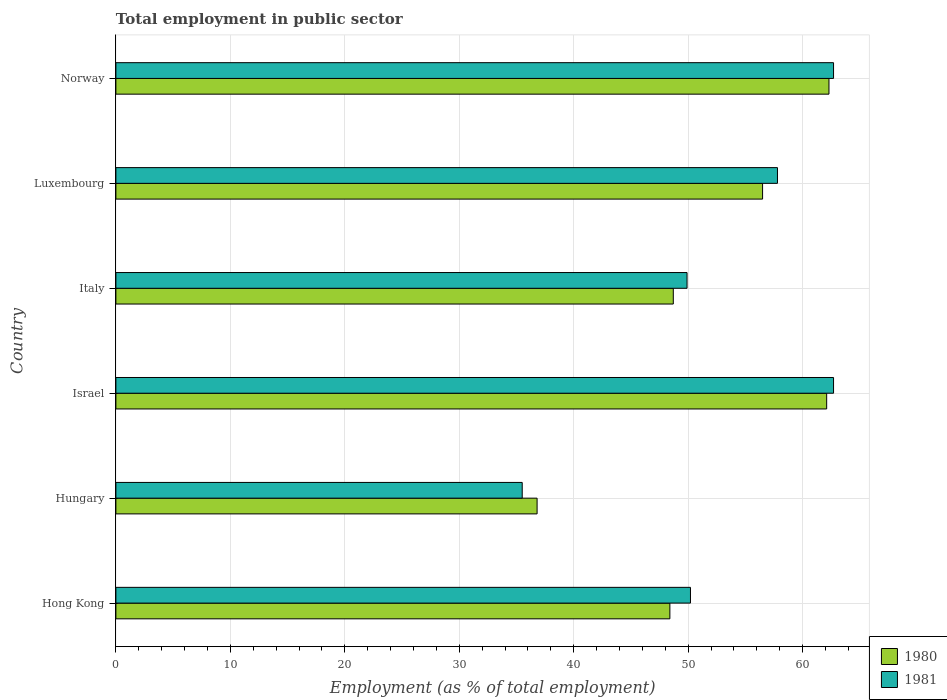How many groups of bars are there?
Keep it short and to the point. 6. How many bars are there on the 2nd tick from the top?
Offer a terse response. 2. What is the label of the 6th group of bars from the top?
Ensure brevity in your answer.  Hong Kong. What is the employment in public sector in 1980 in Luxembourg?
Keep it short and to the point. 56.5. Across all countries, what is the maximum employment in public sector in 1981?
Give a very brief answer. 62.7. Across all countries, what is the minimum employment in public sector in 1981?
Make the answer very short. 35.5. In which country was the employment in public sector in 1980 maximum?
Your response must be concise. Norway. In which country was the employment in public sector in 1980 minimum?
Your answer should be very brief. Hungary. What is the total employment in public sector in 1980 in the graph?
Make the answer very short. 314.8. What is the difference between the employment in public sector in 1981 in Hong Kong and that in Italy?
Provide a short and direct response. 0.3. What is the difference between the employment in public sector in 1981 in Luxembourg and the employment in public sector in 1980 in Italy?
Provide a short and direct response. 9.1. What is the average employment in public sector in 1981 per country?
Ensure brevity in your answer.  53.13. What is the difference between the employment in public sector in 1980 and employment in public sector in 1981 in Hungary?
Your answer should be compact. 1.3. What is the ratio of the employment in public sector in 1980 in Israel to that in Luxembourg?
Keep it short and to the point. 1.1. What is the difference between the highest and the second highest employment in public sector in 1980?
Give a very brief answer. 0.2. What is the difference between the highest and the lowest employment in public sector in 1980?
Make the answer very short. 25.5. What does the 1st bar from the top in Hungary represents?
Give a very brief answer. 1981. How many bars are there?
Provide a short and direct response. 12. Are the values on the major ticks of X-axis written in scientific E-notation?
Give a very brief answer. No. Where does the legend appear in the graph?
Offer a terse response. Bottom right. How many legend labels are there?
Provide a succinct answer. 2. What is the title of the graph?
Your answer should be compact. Total employment in public sector. What is the label or title of the X-axis?
Your response must be concise. Employment (as % of total employment). What is the Employment (as % of total employment) of 1980 in Hong Kong?
Your answer should be compact. 48.4. What is the Employment (as % of total employment) of 1981 in Hong Kong?
Keep it short and to the point. 50.2. What is the Employment (as % of total employment) in 1980 in Hungary?
Offer a very short reply. 36.8. What is the Employment (as % of total employment) in 1981 in Hungary?
Provide a succinct answer. 35.5. What is the Employment (as % of total employment) in 1980 in Israel?
Your answer should be compact. 62.1. What is the Employment (as % of total employment) in 1981 in Israel?
Your answer should be very brief. 62.7. What is the Employment (as % of total employment) of 1980 in Italy?
Your answer should be very brief. 48.7. What is the Employment (as % of total employment) of 1981 in Italy?
Offer a terse response. 49.9. What is the Employment (as % of total employment) of 1980 in Luxembourg?
Provide a succinct answer. 56.5. What is the Employment (as % of total employment) in 1981 in Luxembourg?
Your answer should be very brief. 57.8. What is the Employment (as % of total employment) in 1980 in Norway?
Offer a terse response. 62.3. What is the Employment (as % of total employment) of 1981 in Norway?
Make the answer very short. 62.7. Across all countries, what is the maximum Employment (as % of total employment) of 1980?
Provide a short and direct response. 62.3. Across all countries, what is the maximum Employment (as % of total employment) of 1981?
Your answer should be very brief. 62.7. Across all countries, what is the minimum Employment (as % of total employment) of 1980?
Your answer should be compact. 36.8. Across all countries, what is the minimum Employment (as % of total employment) of 1981?
Your answer should be very brief. 35.5. What is the total Employment (as % of total employment) of 1980 in the graph?
Make the answer very short. 314.8. What is the total Employment (as % of total employment) in 1981 in the graph?
Your answer should be very brief. 318.8. What is the difference between the Employment (as % of total employment) of 1980 in Hong Kong and that in Hungary?
Provide a short and direct response. 11.6. What is the difference between the Employment (as % of total employment) in 1981 in Hong Kong and that in Hungary?
Keep it short and to the point. 14.7. What is the difference between the Employment (as % of total employment) of 1980 in Hong Kong and that in Israel?
Give a very brief answer. -13.7. What is the difference between the Employment (as % of total employment) of 1981 in Hong Kong and that in Israel?
Your answer should be compact. -12.5. What is the difference between the Employment (as % of total employment) in 1981 in Hong Kong and that in Italy?
Keep it short and to the point. 0.3. What is the difference between the Employment (as % of total employment) of 1980 in Hong Kong and that in Luxembourg?
Your answer should be very brief. -8.1. What is the difference between the Employment (as % of total employment) in 1981 in Hong Kong and that in Luxembourg?
Keep it short and to the point. -7.6. What is the difference between the Employment (as % of total employment) of 1980 in Hong Kong and that in Norway?
Ensure brevity in your answer.  -13.9. What is the difference between the Employment (as % of total employment) in 1980 in Hungary and that in Israel?
Provide a short and direct response. -25.3. What is the difference between the Employment (as % of total employment) in 1981 in Hungary and that in Israel?
Offer a terse response. -27.2. What is the difference between the Employment (as % of total employment) in 1981 in Hungary and that in Italy?
Make the answer very short. -14.4. What is the difference between the Employment (as % of total employment) of 1980 in Hungary and that in Luxembourg?
Offer a terse response. -19.7. What is the difference between the Employment (as % of total employment) of 1981 in Hungary and that in Luxembourg?
Offer a terse response. -22.3. What is the difference between the Employment (as % of total employment) of 1980 in Hungary and that in Norway?
Give a very brief answer. -25.5. What is the difference between the Employment (as % of total employment) in 1981 in Hungary and that in Norway?
Offer a terse response. -27.2. What is the difference between the Employment (as % of total employment) of 1981 in Israel and that in Italy?
Offer a terse response. 12.8. What is the difference between the Employment (as % of total employment) of 1980 in Israel and that in Norway?
Keep it short and to the point. -0.2. What is the difference between the Employment (as % of total employment) of 1981 in Israel and that in Norway?
Give a very brief answer. 0. What is the difference between the Employment (as % of total employment) in 1980 in Italy and that in Luxembourg?
Make the answer very short. -7.8. What is the difference between the Employment (as % of total employment) in 1981 in Italy and that in Luxembourg?
Your response must be concise. -7.9. What is the difference between the Employment (as % of total employment) of 1981 in Italy and that in Norway?
Your answer should be compact. -12.8. What is the difference between the Employment (as % of total employment) in 1980 in Luxembourg and that in Norway?
Keep it short and to the point. -5.8. What is the difference between the Employment (as % of total employment) of 1981 in Luxembourg and that in Norway?
Your answer should be compact. -4.9. What is the difference between the Employment (as % of total employment) of 1980 in Hong Kong and the Employment (as % of total employment) of 1981 in Hungary?
Your response must be concise. 12.9. What is the difference between the Employment (as % of total employment) of 1980 in Hong Kong and the Employment (as % of total employment) of 1981 in Israel?
Ensure brevity in your answer.  -14.3. What is the difference between the Employment (as % of total employment) in 1980 in Hong Kong and the Employment (as % of total employment) in 1981 in Norway?
Provide a short and direct response. -14.3. What is the difference between the Employment (as % of total employment) of 1980 in Hungary and the Employment (as % of total employment) of 1981 in Israel?
Your answer should be very brief. -25.9. What is the difference between the Employment (as % of total employment) of 1980 in Hungary and the Employment (as % of total employment) of 1981 in Norway?
Your response must be concise. -25.9. What is the difference between the Employment (as % of total employment) in 1980 in Israel and the Employment (as % of total employment) in 1981 in Italy?
Offer a terse response. 12.2. What is the difference between the Employment (as % of total employment) of 1980 in Israel and the Employment (as % of total employment) of 1981 in Norway?
Offer a terse response. -0.6. What is the difference between the Employment (as % of total employment) in 1980 in Italy and the Employment (as % of total employment) in 1981 in Norway?
Offer a terse response. -14. What is the average Employment (as % of total employment) in 1980 per country?
Your answer should be very brief. 52.47. What is the average Employment (as % of total employment) of 1981 per country?
Give a very brief answer. 53.13. What is the difference between the Employment (as % of total employment) of 1980 and Employment (as % of total employment) of 1981 in Hong Kong?
Provide a short and direct response. -1.8. What is the difference between the Employment (as % of total employment) of 1980 and Employment (as % of total employment) of 1981 in Hungary?
Your response must be concise. 1.3. What is the difference between the Employment (as % of total employment) of 1980 and Employment (as % of total employment) of 1981 in Norway?
Provide a short and direct response. -0.4. What is the ratio of the Employment (as % of total employment) of 1980 in Hong Kong to that in Hungary?
Ensure brevity in your answer.  1.32. What is the ratio of the Employment (as % of total employment) in 1981 in Hong Kong to that in Hungary?
Give a very brief answer. 1.41. What is the ratio of the Employment (as % of total employment) of 1980 in Hong Kong to that in Israel?
Provide a succinct answer. 0.78. What is the ratio of the Employment (as % of total employment) in 1981 in Hong Kong to that in Israel?
Give a very brief answer. 0.8. What is the ratio of the Employment (as % of total employment) of 1980 in Hong Kong to that in Italy?
Offer a very short reply. 0.99. What is the ratio of the Employment (as % of total employment) in 1981 in Hong Kong to that in Italy?
Ensure brevity in your answer.  1.01. What is the ratio of the Employment (as % of total employment) in 1980 in Hong Kong to that in Luxembourg?
Your response must be concise. 0.86. What is the ratio of the Employment (as % of total employment) in 1981 in Hong Kong to that in Luxembourg?
Make the answer very short. 0.87. What is the ratio of the Employment (as % of total employment) of 1980 in Hong Kong to that in Norway?
Offer a terse response. 0.78. What is the ratio of the Employment (as % of total employment) of 1981 in Hong Kong to that in Norway?
Keep it short and to the point. 0.8. What is the ratio of the Employment (as % of total employment) in 1980 in Hungary to that in Israel?
Offer a very short reply. 0.59. What is the ratio of the Employment (as % of total employment) in 1981 in Hungary to that in Israel?
Your answer should be compact. 0.57. What is the ratio of the Employment (as % of total employment) in 1980 in Hungary to that in Italy?
Give a very brief answer. 0.76. What is the ratio of the Employment (as % of total employment) in 1981 in Hungary to that in Italy?
Keep it short and to the point. 0.71. What is the ratio of the Employment (as % of total employment) in 1980 in Hungary to that in Luxembourg?
Offer a terse response. 0.65. What is the ratio of the Employment (as % of total employment) of 1981 in Hungary to that in Luxembourg?
Your answer should be compact. 0.61. What is the ratio of the Employment (as % of total employment) of 1980 in Hungary to that in Norway?
Offer a very short reply. 0.59. What is the ratio of the Employment (as % of total employment) of 1981 in Hungary to that in Norway?
Your answer should be very brief. 0.57. What is the ratio of the Employment (as % of total employment) of 1980 in Israel to that in Italy?
Offer a very short reply. 1.28. What is the ratio of the Employment (as % of total employment) in 1981 in Israel to that in Italy?
Offer a terse response. 1.26. What is the ratio of the Employment (as % of total employment) in 1980 in Israel to that in Luxembourg?
Provide a succinct answer. 1.1. What is the ratio of the Employment (as % of total employment) of 1981 in Israel to that in Luxembourg?
Make the answer very short. 1.08. What is the ratio of the Employment (as % of total employment) in 1981 in Israel to that in Norway?
Give a very brief answer. 1. What is the ratio of the Employment (as % of total employment) of 1980 in Italy to that in Luxembourg?
Offer a very short reply. 0.86. What is the ratio of the Employment (as % of total employment) of 1981 in Italy to that in Luxembourg?
Your response must be concise. 0.86. What is the ratio of the Employment (as % of total employment) of 1980 in Italy to that in Norway?
Give a very brief answer. 0.78. What is the ratio of the Employment (as % of total employment) of 1981 in Italy to that in Norway?
Offer a terse response. 0.8. What is the ratio of the Employment (as % of total employment) of 1980 in Luxembourg to that in Norway?
Keep it short and to the point. 0.91. What is the ratio of the Employment (as % of total employment) in 1981 in Luxembourg to that in Norway?
Provide a succinct answer. 0.92. What is the difference between the highest and the second highest Employment (as % of total employment) in 1981?
Make the answer very short. 0. What is the difference between the highest and the lowest Employment (as % of total employment) in 1981?
Make the answer very short. 27.2. 